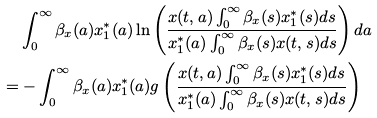Convert formula to latex. <formula><loc_0><loc_0><loc_500><loc_500>& \int _ { 0 } ^ { \infty } \beta _ { x } ( a ) x ^ { * } _ { 1 } ( a ) \ln \left ( \frac { x ( t , a ) \int _ { 0 } ^ { \infty } \beta _ { x } ( s ) x ^ { * } _ { 1 } ( s ) d s } { x ^ { * } _ { 1 } ( a ) \int _ { 0 } ^ { \infty } \beta _ { x } ( s ) x ( t , s ) d s } \right ) d a \\ = & - \int _ { 0 } ^ { \infty } \beta _ { x } ( a ) x ^ { * } _ { 1 } ( a ) g \left ( \frac { x ( t , a ) \int _ { 0 } ^ { \infty } \beta _ { x } ( s ) x ^ { * } _ { 1 } ( s ) d s } { x ^ { * } _ { 1 } ( a ) \int _ { 0 } ^ { \infty } \beta _ { x } ( s ) x ( t , s ) d s } \right )</formula> 